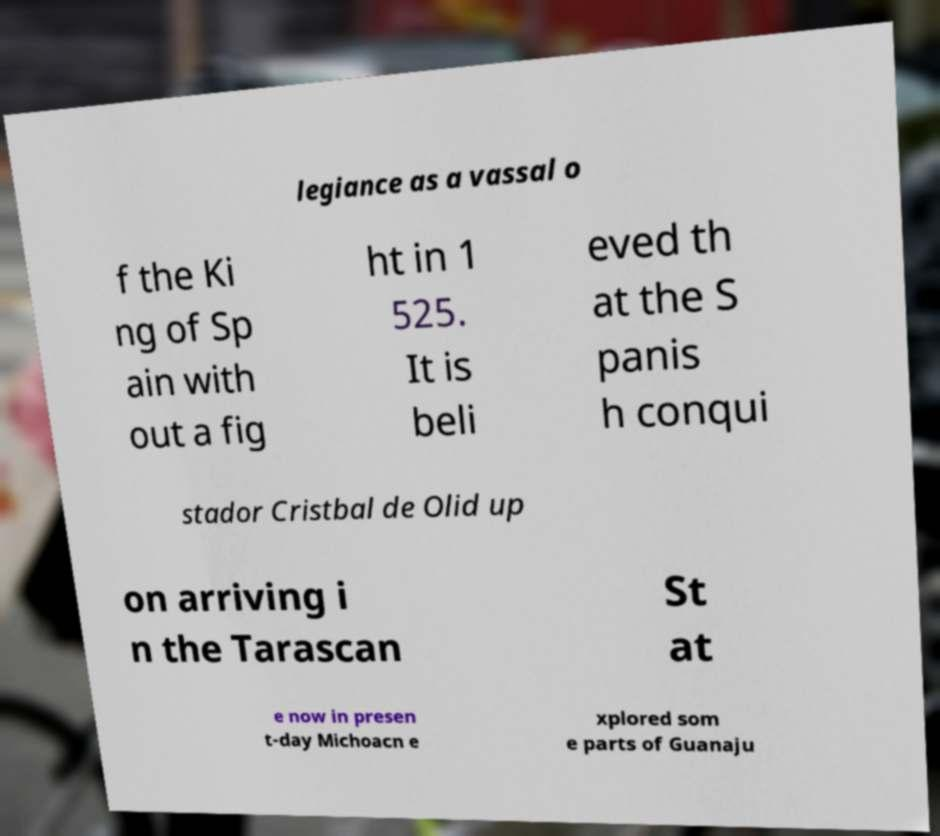Could you extract and type out the text from this image? legiance as a vassal o f the Ki ng of Sp ain with out a fig ht in 1 525. It is beli eved th at the S panis h conqui stador Cristbal de Olid up on arriving i n the Tarascan St at e now in presen t-day Michoacn e xplored som e parts of Guanaju 